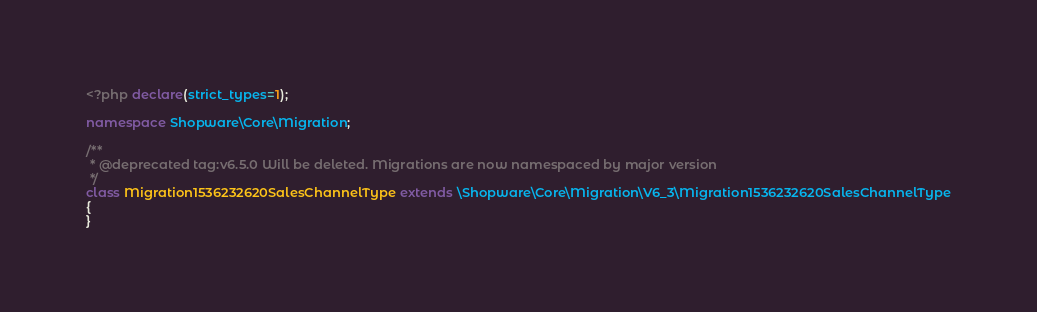<code> <loc_0><loc_0><loc_500><loc_500><_PHP_><?php declare(strict_types=1);

namespace Shopware\Core\Migration;

/**
 * @deprecated tag:v6.5.0 Will be deleted. Migrations are now namespaced by major version
 */
class Migration1536232620SalesChannelType extends \Shopware\Core\Migration\V6_3\Migration1536232620SalesChannelType
{
}
</code> 